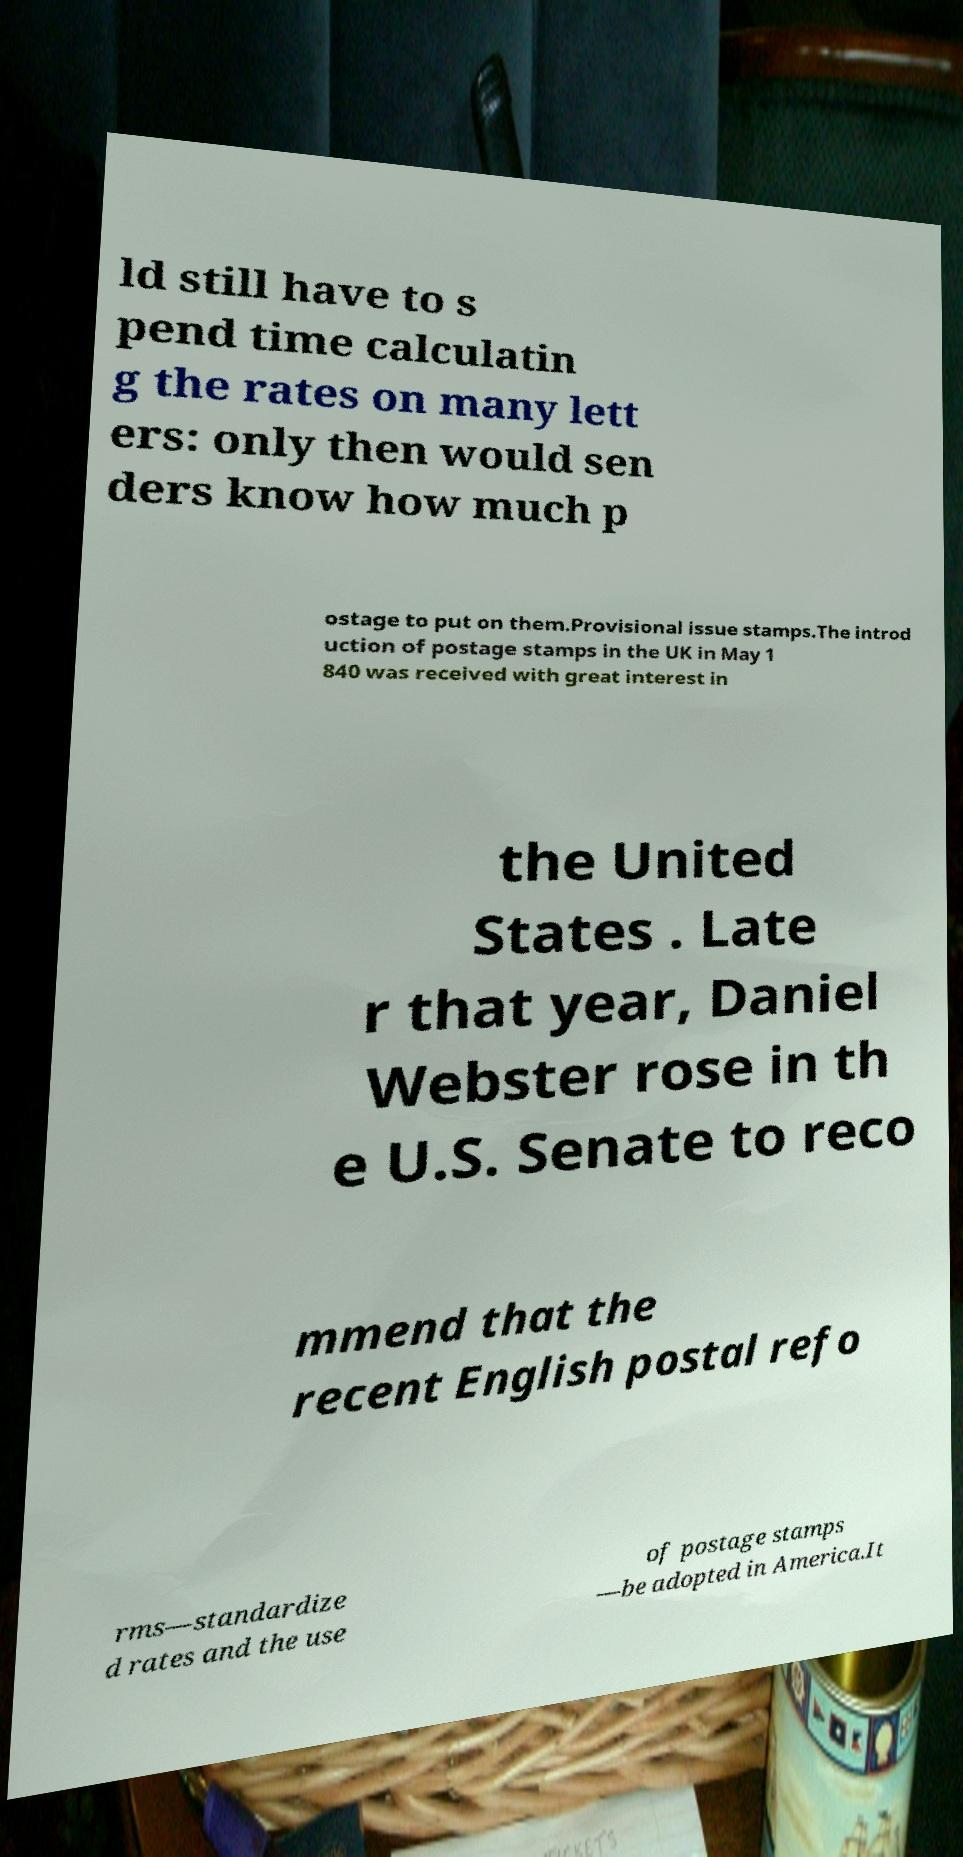Can you read and provide the text displayed in the image?This photo seems to have some interesting text. Can you extract and type it out for me? ld still have to s pend time calculatin g the rates on many lett ers: only then would sen ders know how much p ostage to put on them.Provisional issue stamps.The introd uction of postage stamps in the UK in May 1 840 was received with great interest in the United States . Late r that year, Daniel Webster rose in th e U.S. Senate to reco mmend that the recent English postal refo rms—standardize d rates and the use of postage stamps —be adopted in America.It 